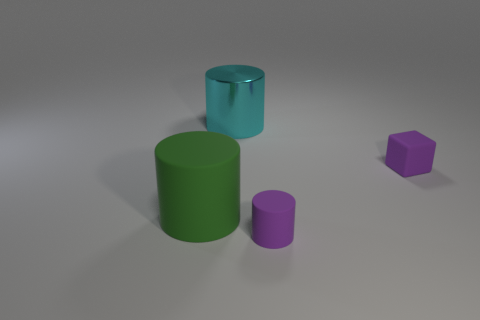Subtract all tiny purple cylinders. How many cylinders are left? 2 Add 4 small gray metallic things. How many objects exist? 8 Subtract all cylinders. How many objects are left? 1 Add 1 cubes. How many cubes are left? 2 Add 1 big metallic cylinders. How many big metallic cylinders exist? 2 Subtract 0 yellow blocks. How many objects are left? 4 Subtract all tiny matte cylinders. Subtract all small things. How many objects are left? 1 